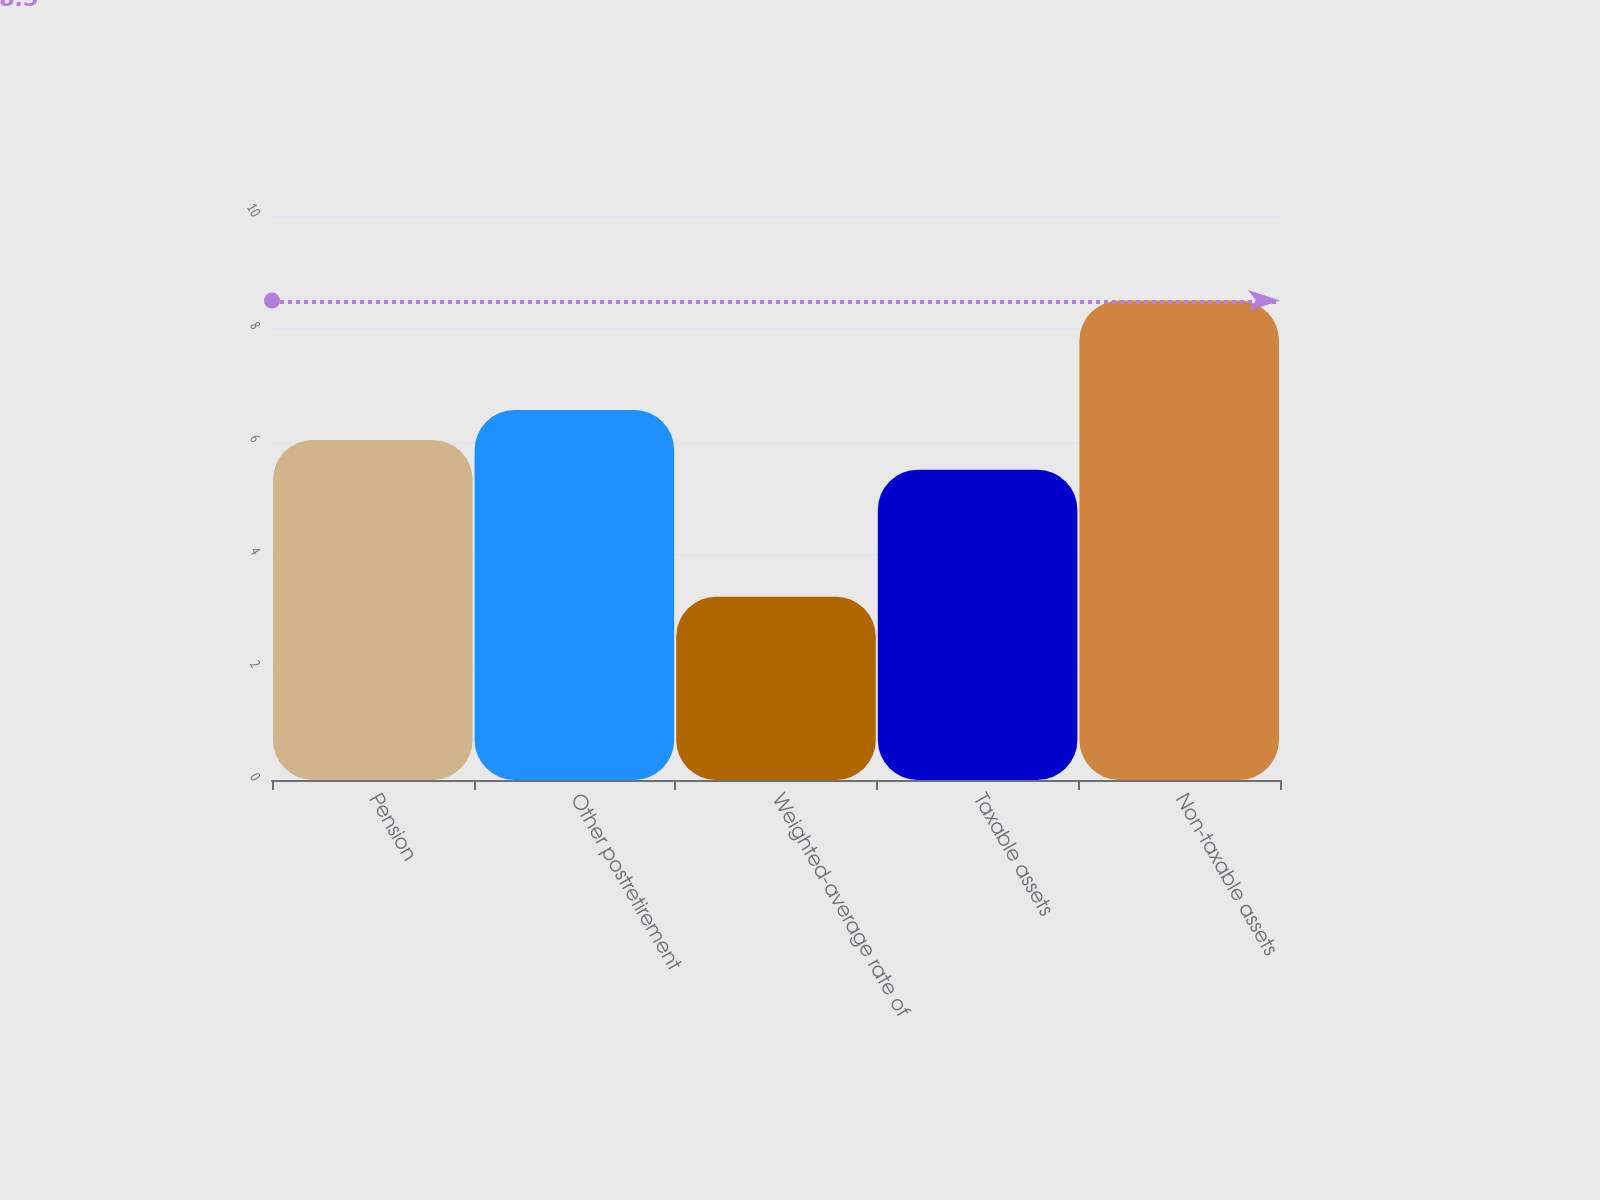<chart> <loc_0><loc_0><loc_500><loc_500><bar_chart><fcel>Pension<fcel>Other postretirement<fcel>Weighted-average rate of<fcel>Taxable assets<fcel>Non-taxable assets<nl><fcel>6.03<fcel>6.56<fcel>3.25<fcel>5.5<fcel>8.5<nl></chart> 